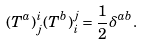Convert formula to latex. <formula><loc_0><loc_0><loc_500><loc_500>( T ^ { a } ) ^ { i } _ { j } ( T ^ { b } ) ^ { j } _ { i } = \frac { 1 } { 2 } \delta ^ { a b } .</formula> 